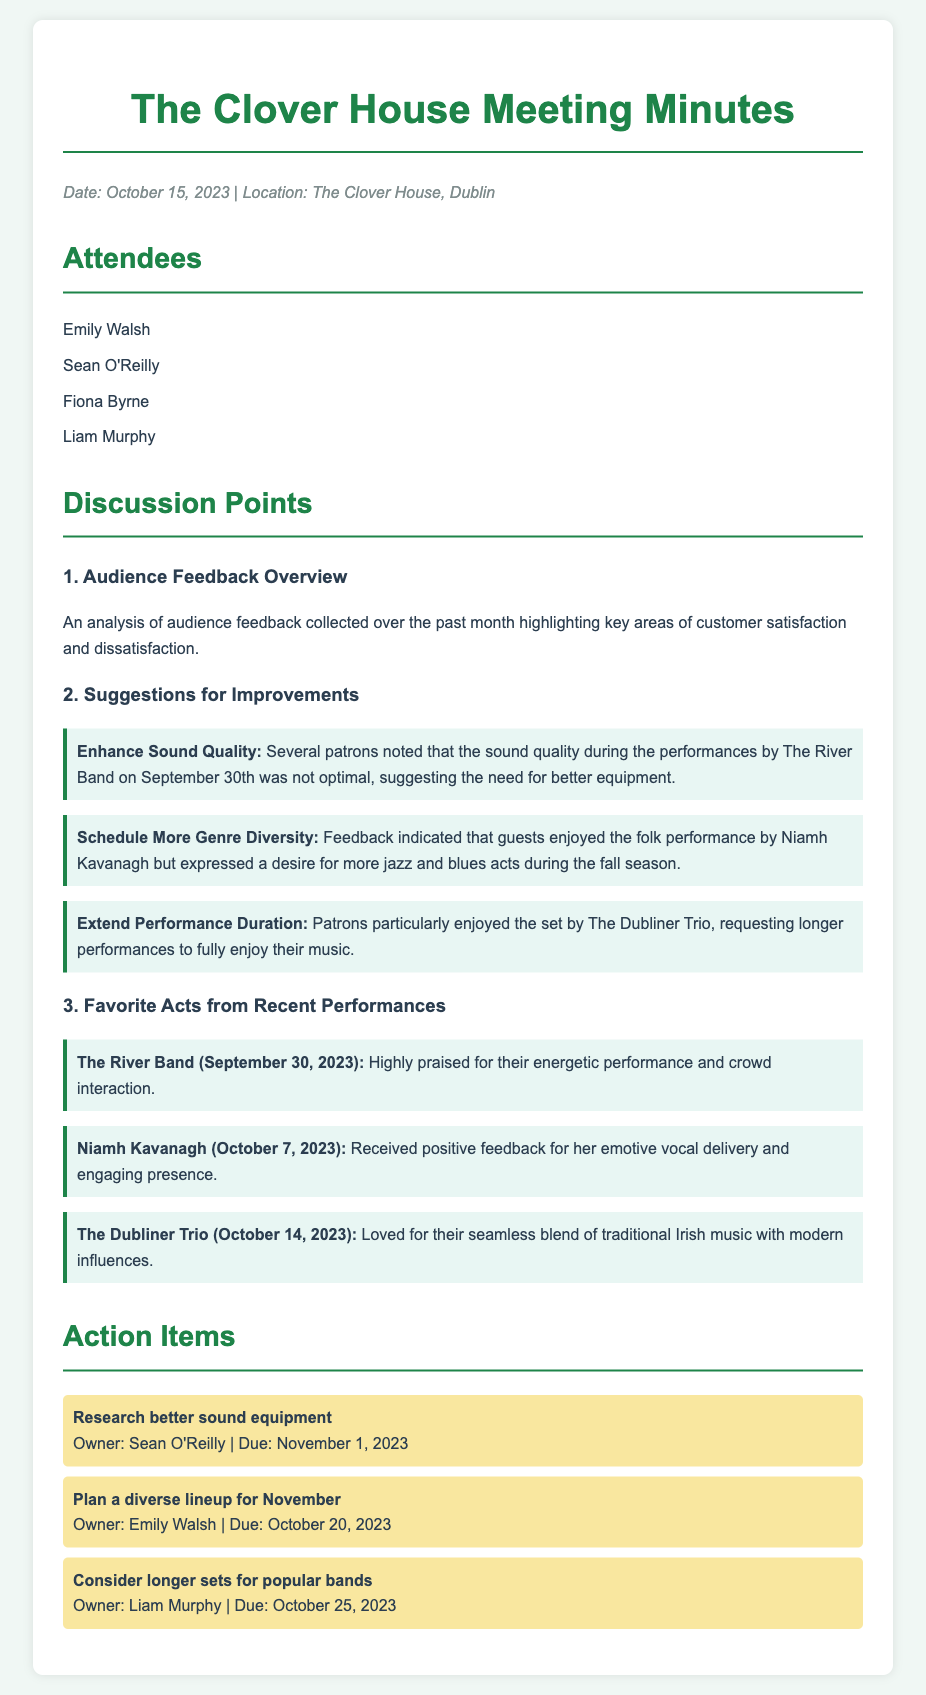what date was the meeting held? The date of the meeting is mentioned at the beginning of the document, which is October 15, 2023.
Answer: October 15, 2023 who is responsible for researching better sound equipment? The action item for researching better sound equipment specifies the owner as Sean O'Reilly.
Answer: Sean O'Reilly what is one suggestion for improvement related to performance duration? One suggestion for improvement mentioned in the document is to extend performance duration for popular bands.
Answer: Extend performance duration which act received positive feedback for emotive vocal delivery? The act known for its emotive vocal delivery as noted in the feedback is Niamh Kavanagh.
Answer: Niamh Kavanagh how many action items are listed in the meeting minutes? The number of action items listed can be found under the Action Items section, which total three.
Answer: 3 what is the name of the venue where the meeting took place? The name of the venue is indicated at the top of the document as The Clover House.
Answer: The Clover House what was the audience's general sentiment towards The River Band's performance? The audience's sentiment towards The River Band's performance was highly positive, noted for their energetic performance and crowd interaction.
Answer: Highly praised when is the due date for planning a diverse lineup for November? The due date for planning a diverse lineup is specified as October 20, 2023.
Answer: October 20, 2023 